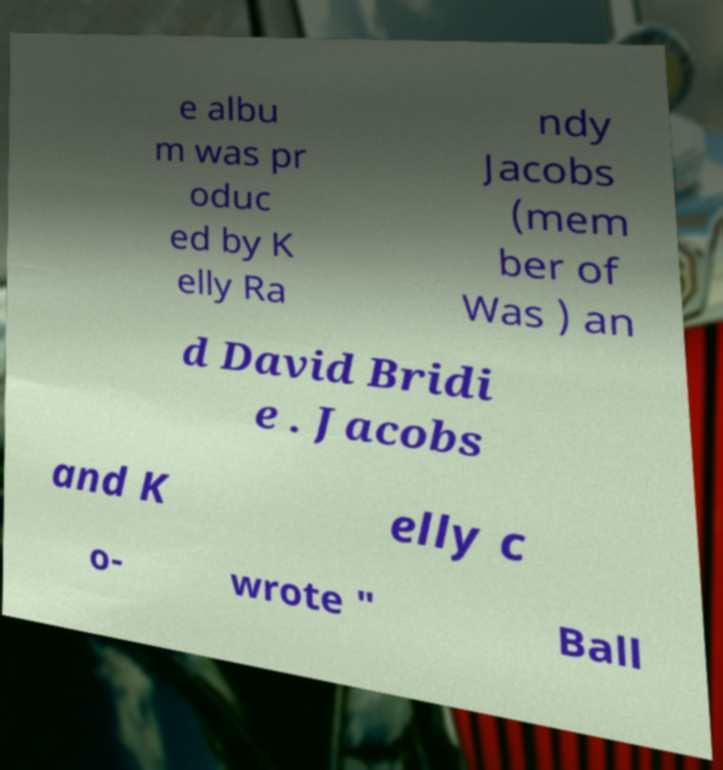Could you assist in decoding the text presented in this image and type it out clearly? e albu m was pr oduc ed by K elly Ra ndy Jacobs (mem ber of Was ) an d David Bridi e . Jacobs and K elly c o- wrote " Ball 